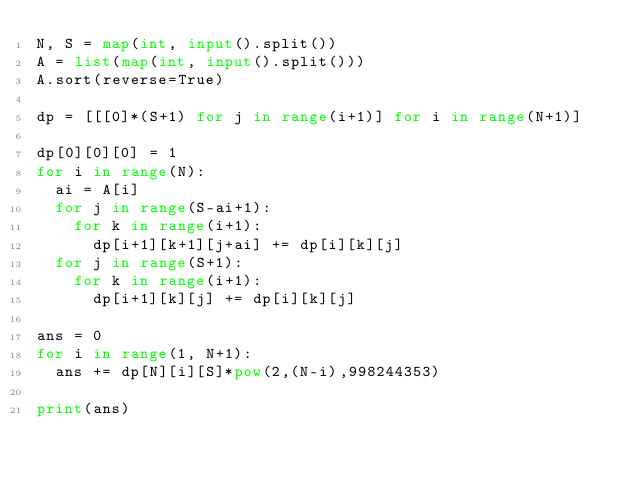<code> <loc_0><loc_0><loc_500><loc_500><_Python_>N, S = map(int, input().split())
A = list(map(int, input().split()))
A.sort(reverse=True)

dp = [[[0]*(S+1) for j in range(i+1)] for i in range(N+1)]

dp[0][0][0] = 1
for i in range(N):
  ai = A[i]
  for j in range(S-ai+1):
    for k in range(i+1):
      dp[i+1][k+1][j+ai] += dp[i][k][j]
  for j in range(S+1):
    for k in range(i+1):
      dp[i+1][k][j] += dp[i][k][j]

ans = 0
for i in range(1, N+1):
  ans += dp[N][i][S]*pow(2,(N-i),998244353)
  
print(ans)
      
</code> 